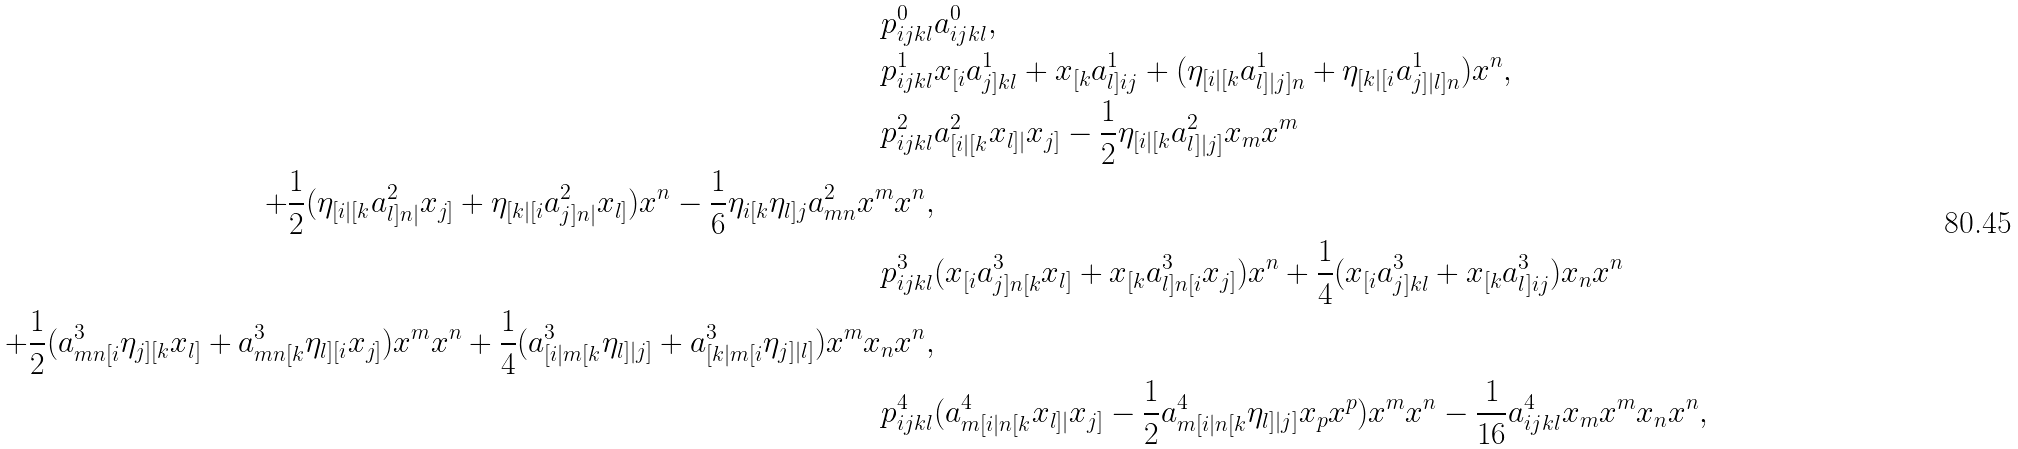Convert formula to latex. <formula><loc_0><loc_0><loc_500><loc_500>p ^ { 0 } _ { i j k l } & a ^ { 0 } _ { i j k l } , \\ p ^ { 1 } _ { i j k l } & x _ { [ i } a ^ { 1 } _ { j ] k l } + x _ { [ k } a ^ { 1 } _ { l ] i j } + ( \eta _ { [ i | [ k } a ^ { 1 } _ { l ] | j ] n } + \eta _ { [ k | [ i } a ^ { 1 } _ { j ] | l ] n } ) x ^ { n } , \\ p ^ { 2 } _ { i j k l } & a ^ { 2 } _ { [ i | [ k } x _ { l ] | } x _ { j ] } - \frac { 1 } { 2 } \eta _ { [ i | [ k } a ^ { 2 } _ { l ] | j ] } x _ { m } x ^ { m } \\ + \frac { 1 } { 2 } ( \eta _ { [ i | [ k } a ^ { 2 } _ { l ] n | } x _ { j ] } + \eta _ { [ k | [ i } a ^ { 2 } _ { j ] n | } x _ { l ] } ) x ^ { n } - \frac { 1 } { 6 } \eta _ { i [ k } \eta _ { l ] j } a ^ { 2 } _ { m n } x ^ { m } x ^ { n } , \\ p ^ { 3 } _ { i j k l } & ( x _ { [ i } a ^ { 3 } _ { j ] n [ k } x _ { l ] } + x _ { [ k } a ^ { 3 } _ { l ] n [ i } x _ { j ] } ) x ^ { n } + \frac { 1 } { 4 } ( x _ { [ i } a ^ { 3 } _ { j ] k l } + x _ { [ k } a ^ { 3 } _ { l ] i j } ) x _ { n } x ^ { n } \\ + \frac { 1 } { 2 } ( a ^ { 3 } _ { m n [ i } \eta _ { j ] [ k } x _ { l ] } + a ^ { 3 } _ { m n [ k } \eta _ { l ] [ i } x _ { j ] } ) x ^ { m } x ^ { n } + \frac { 1 } { 4 } ( a ^ { 3 } _ { [ i | m [ k } \eta _ { l ] | j ] } + a ^ { 3 } _ { [ k | m [ i } \eta _ { j ] | l ] } ) x ^ { m } x _ { n } x ^ { n } , \\ p ^ { 4 } _ { i j k l } & ( a ^ { 4 } _ { m [ i | n [ k } x _ { l ] | } x _ { j ] } - \frac { 1 } { 2 } a ^ { 4 } _ { m [ i | n [ k } \eta _ { l ] | j ] } x _ { p } x ^ { p } ) x ^ { m } x ^ { n } - \frac { 1 } { 1 6 } a ^ { 4 } _ { i j k l } x _ { m } x ^ { m } x _ { n } x ^ { n } ,</formula> 